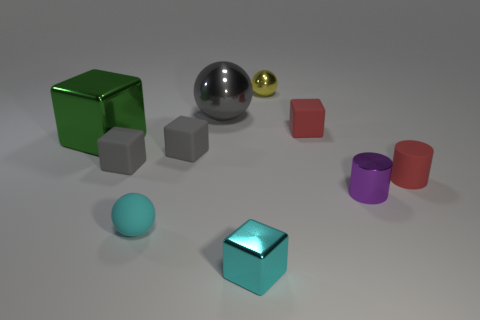How many other things are there of the same material as the tiny cyan ball?
Keep it short and to the point. 4. What size is the shiny ball in front of the ball that is to the right of the small metallic cube?
Offer a very short reply. Large. Does the matte ball have the same color as the metal ball to the left of the yellow ball?
Provide a short and direct response. No. There is a metal thing that is both in front of the yellow metallic sphere and to the right of the cyan cube; what is its size?
Give a very brief answer. Small. There is a purple thing; are there any small cyan cubes right of it?
Provide a short and direct response. No. Is there a gray ball on the right side of the rubber thing in front of the tiny purple metal cylinder?
Offer a terse response. Yes. Are there the same number of tiny metallic objects in front of the small purple thing and big green blocks behind the tiny red matte block?
Give a very brief answer. No. What color is the other block that is the same material as the cyan block?
Offer a very short reply. Green. Are there any small red balls made of the same material as the tiny yellow thing?
Give a very brief answer. No. How many objects are either small cyan rubber cylinders or tiny shiny things?
Provide a short and direct response. 3. 